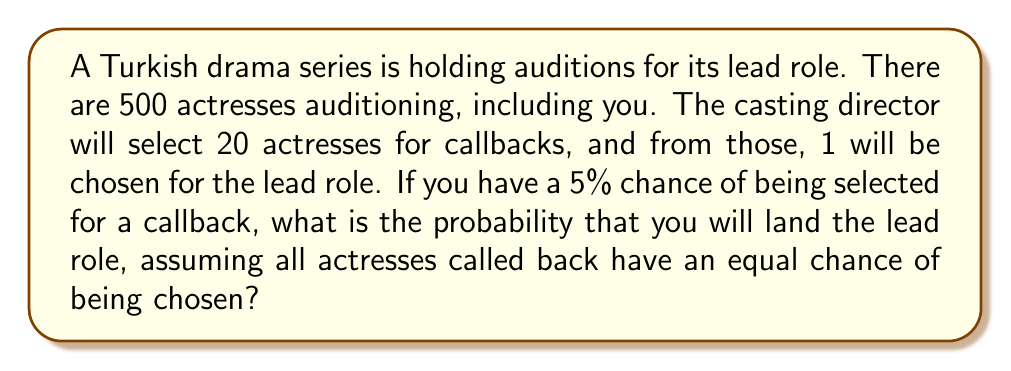Could you help me with this problem? Let's approach this step-by-step:

1) First, we need to calculate the probability of being selected for a callback:
   $P(\text{callback}) = 0.05$ (given in the question)

2) Next, if selected for a callback, we need to calculate the probability of being chosen for the lead role:
   $P(\text{lead}|\text{callback}) = \frac{1}{20}$ (as 1 out of 20 callback actresses will be chosen)

3) To find the total probability of landing the lead role, we use the multiplication rule of probability:
   
   $P(\text{lead}) = P(\text{callback}) \times P(\text{lead}|\text{callback})$

4) Substituting the values:
   
   $P(\text{lead}) = 0.05 \times \frac{1}{20} = \frac{0.05}{20} = 0.0025$

5) Convert to a percentage:
   
   $0.0025 \times 100\% = 0.25\%$

Therefore, the probability of landing the lead role is 0.25% or 1 in 400.
Answer: 0.25% 